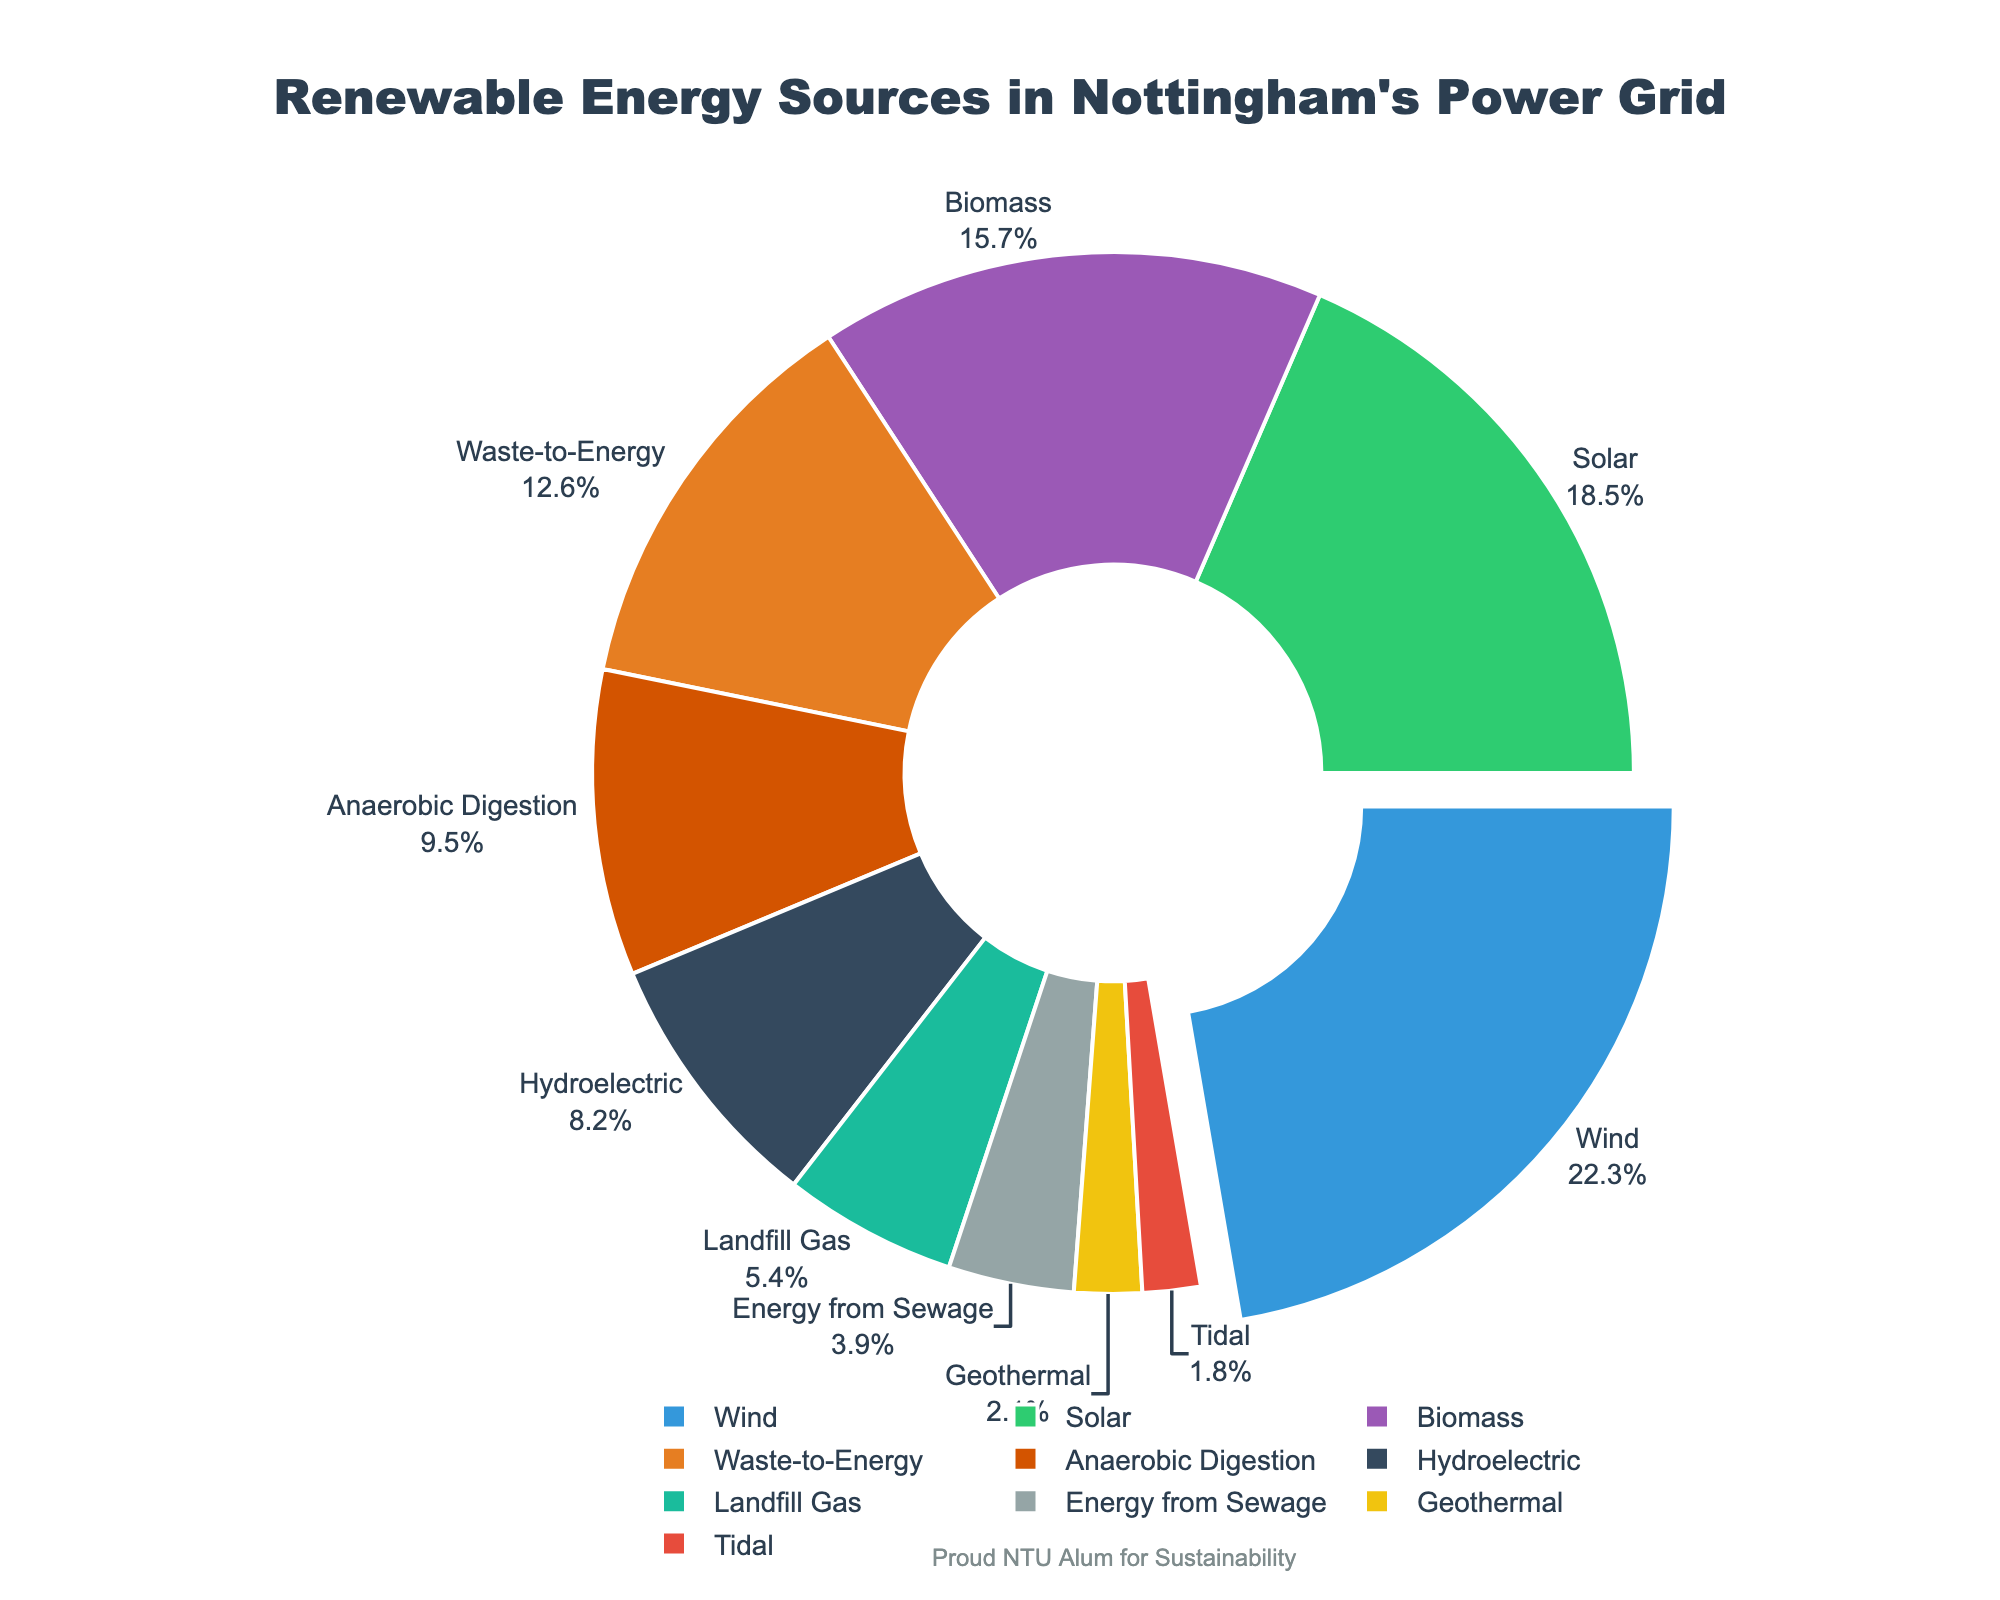Which renewable energy source contributes the most to Nottingham's power grid? The pie chart shows each energy source's percentage, and the largest slice represents Wind with 22.3%.
Answer: Wind What is the combined percentage of Solar and Biomass energy sources? To find the combined percentage, add the percentages of Solar (18.5%) and Biomass (15.7%): 18.5 + 15.7.
Answer: 34.2% How many energy sources contribute less than 10% each to Nottingham's power grid? Look for segments with less than 10%: Hydroelectric (8.2%), Geothermal (2.1%), Tidal (1.8%), Landfill Gas (5.4%), Energy from Sewage (3.9%), Anaerobic Digestion (9.5%). Count these segments.
Answer: 6 Which energy source has a similar contribution to Solar energy? Compare the percentages close to Solar (18.5%). Biomass (15.7%) is quite close.
Answer: Biomass What is the difference between the highest and the lowest contributing energy sources? The highest is Wind (22.3%), and the lowest is Tidal (1.8%). Subtract the lowest percentage from the highest: 22.3 - 1.8.
Answer: 20.5% What is the average percentage contribution of Geothermal, Waste-to-Energy, and Landfill Gas? Add the percentages: Geothermal (2.1%) + Waste-to-Energy (12.6%) + Landfill Gas (5.4%) and divide by 3: (2.1 + 12.6 + 5.4) / 3.
Answer: 6.7% Which energy source is represented by the largest slice in the pie chart? The largest slice, indicated visually by its size, represents Wind (22.3%).
Answer: Wind Compare the contribution of Hydroelectric and Anaerobic Digestion. Which one is higher, and by how much? Hydroelectric contributes 8.2% and Anaerobic Digestion contributes 9.5%. Subtract the lower percentage from the higher: 9.5 - 8.2.
Answer: Anaerobic Digestion, 1.3% If you sum the contributions of Wind, Solar, and Waste-to-Energy, what is the total percentage? Add the percentages: Wind (22.3%), Solar (18.5%), Waste-to-Energy (12.6%): 22.3 + 18.5 + 12.6.
Answer: 53.4% 